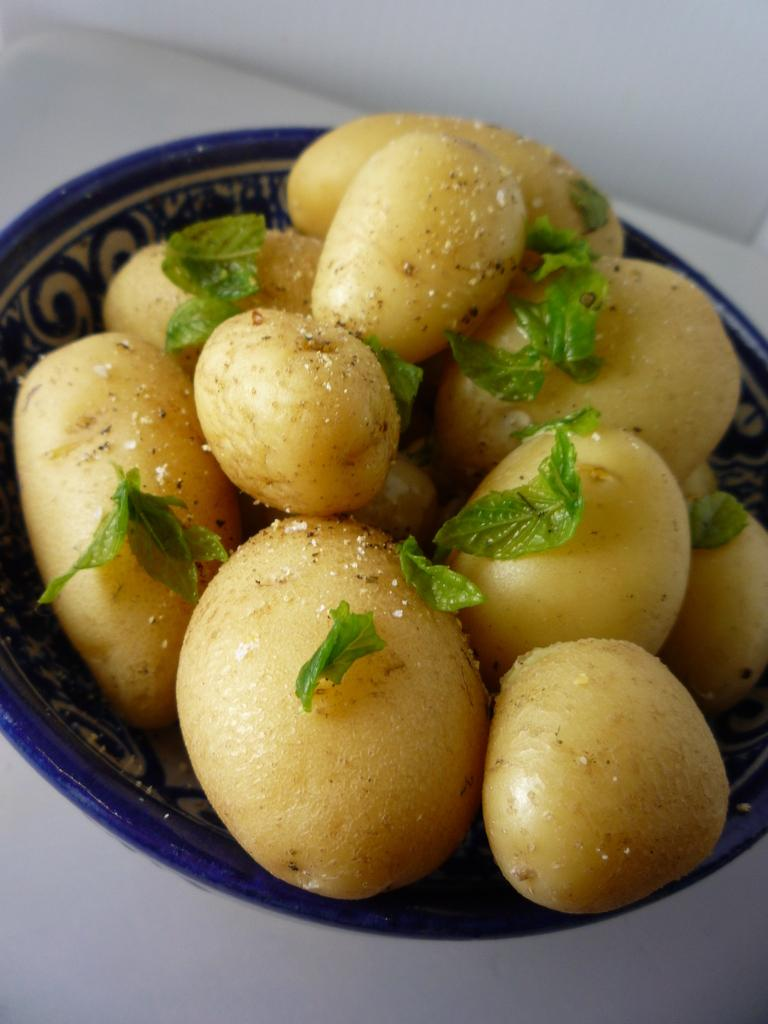What is in the bowl that is visible in the image? The bowl contains potatoes. Are there any other items in the bowl besides potatoes? Yes, there are leaves in the bowl. Where is the bowl located in the image? The bowl is placed on a table. How does the beggar in the image request for money? There is no beggar present in the image; it only features a bowl with potatoes and leaves on a table. 